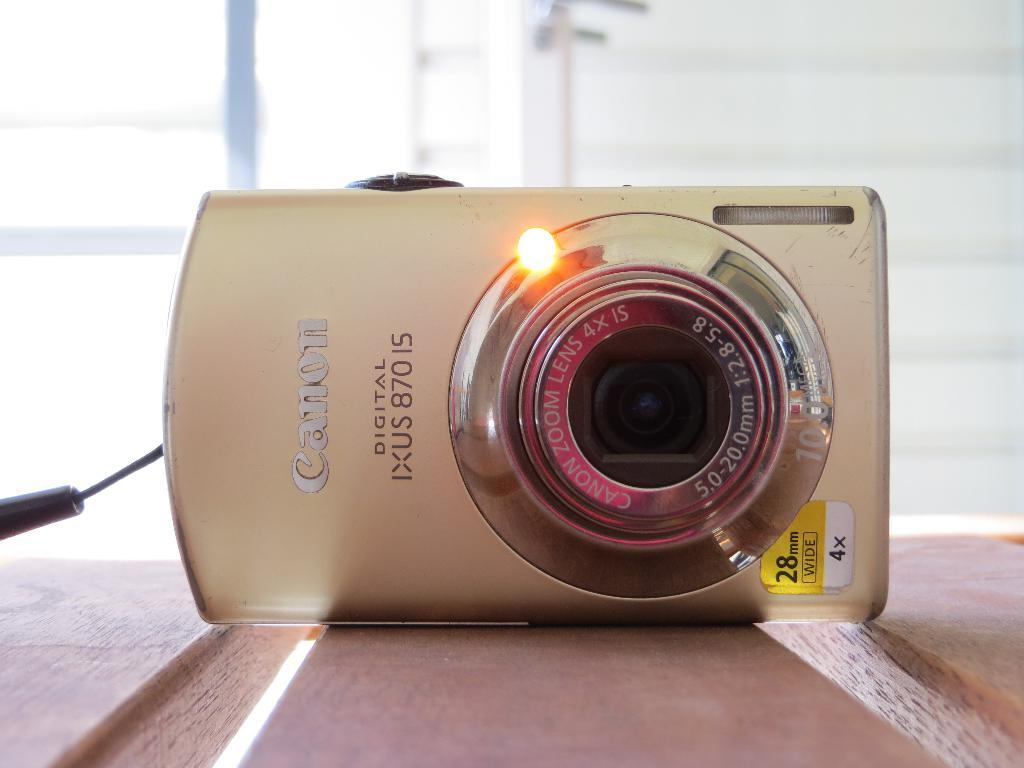What object is the main subject of the image? There is a camera in the image. On what surface is the camera placed? The camera is placed on a wooden surface. What can be observed about the background of the image? The background of the image is blurred. Is there any text visible on the camera? Yes, there is text visible on the camera. What type of juice is being poured from the camera in the image? There is no juice being poured from the camera in the image, as it is a camera and not a container for juice. 